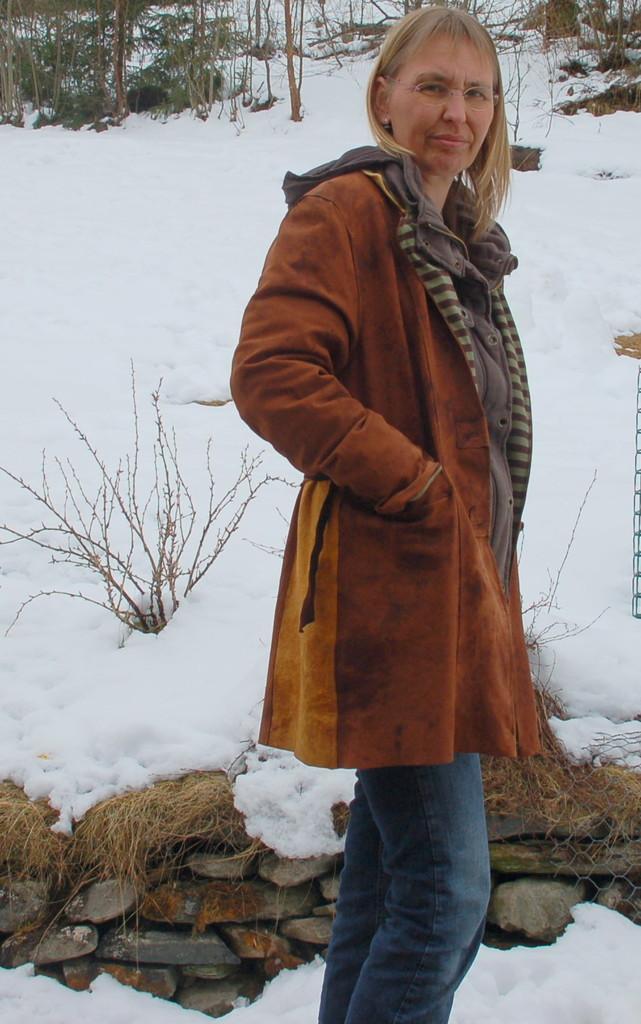How would you summarize this image in a sentence or two? In this image there is a woman standing, is posing for the camera, behind the women there are rocks, on top of the rocks there is snow, in the background of the image there are trees. 